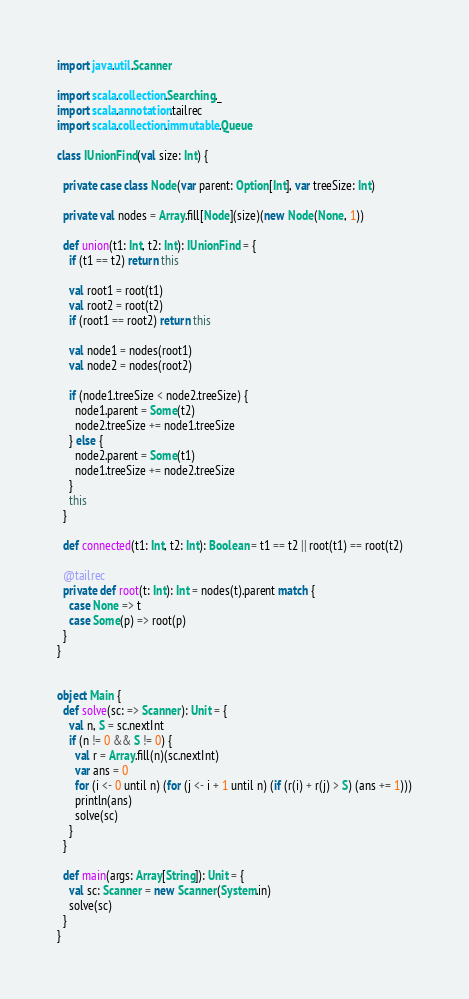<code> <loc_0><loc_0><loc_500><loc_500><_Scala_>import java.util.Scanner

import scala.collection.Searching._
import scala.annotation.tailrec
import scala.collection.immutable.Queue

class IUnionFind(val size: Int) {

  private case class Node(var parent: Option[Int], var treeSize: Int)

  private val nodes = Array.fill[Node](size)(new Node(None, 1))

  def union(t1: Int, t2: Int): IUnionFind = {
    if (t1 == t2) return this

    val root1 = root(t1)
    val root2 = root(t2)
    if (root1 == root2) return this

    val node1 = nodes(root1)
    val node2 = nodes(root2)

    if (node1.treeSize < node2.treeSize) {
      node1.parent = Some(t2)
      node2.treeSize += node1.treeSize
    } else {
      node2.parent = Some(t1)
      node1.treeSize += node2.treeSize
    }
    this
  }

  def connected(t1: Int, t2: Int): Boolean = t1 == t2 || root(t1) == root(t2)

  @tailrec
  private def root(t: Int): Int = nodes(t).parent match {
    case None => t
    case Some(p) => root(p)
  }
}


object Main {
  def solve(sc: => Scanner): Unit = {
    val n, S = sc.nextInt
    if (n != 0 && S != 0) {
      val r = Array.fill(n)(sc.nextInt)
      var ans = 0
      for (i <- 0 until n) (for (j <- i + 1 until n) (if (r(i) + r(j) > S) (ans += 1)))
      println(ans)
      solve(sc)
    }
  }

  def main(args: Array[String]): Unit = {
    val sc: Scanner = new Scanner(System.in)
    solve(sc)
  }
}</code> 